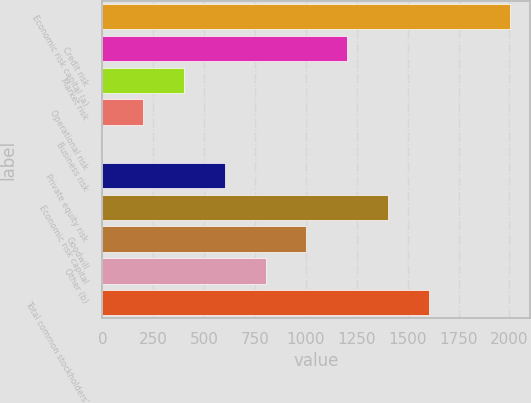<chart> <loc_0><loc_0><loc_500><loc_500><bar_chart><fcel>Economic risk capital (a)<fcel>Credit risk<fcel>Market risk<fcel>Operational risk<fcel>Business risk<fcel>Private equity risk<fcel>Economic risk capital<fcel>Goodwill<fcel>Other (b)<fcel>Total common stockholders'<nl><fcel>2003<fcel>1202.48<fcel>401.96<fcel>201.83<fcel>1.7<fcel>602.09<fcel>1402.61<fcel>1002.35<fcel>802.22<fcel>1602.74<nl></chart> 